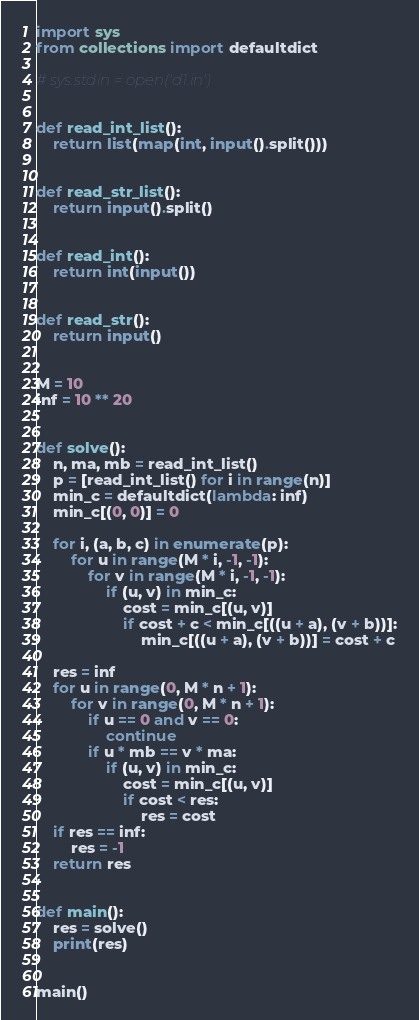<code> <loc_0><loc_0><loc_500><loc_500><_Python_>import sys
from collections import defaultdict

# sys.stdin = open('d1.in')


def read_int_list():
    return list(map(int, input().split()))


def read_str_list():
    return input().split()


def read_int():
    return int(input())


def read_str():
    return input()


M = 10
inf = 10 ** 20


def solve():
    n, ma, mb = read_int_list()
    p = [read_int_list() for i in range(n)]
    min_c = defaultdict(lambda: inf)
    min_c[(0, 0)] = 0

    for i, (a, b, c) in enumerate(p):
        for u in range(M * i, -1, -1):
            for v in range(M * i, -1, -1):
                if (u, v) in min_c:
                    cost = min_c[(u, v)]
                    if cost + c < min_c[((u + a), (v + b))]:
                        min_c[((u + a), (v + b))] = cost + c

    res = inf
    for u in range(0, M * n + 1):
        for v in range(0, M * n + 1):
            if u == 0 and v == 0:
                continue
            if u * mb == v * ma:
                if (u, v) in min_c:
                    cost = min_c[(u, v)]
                    if cost < res:
                        res = cost
    if res == inf:
        res = -1
    return res


def main():
    res = solve()
    print(res)


main()
</code> 